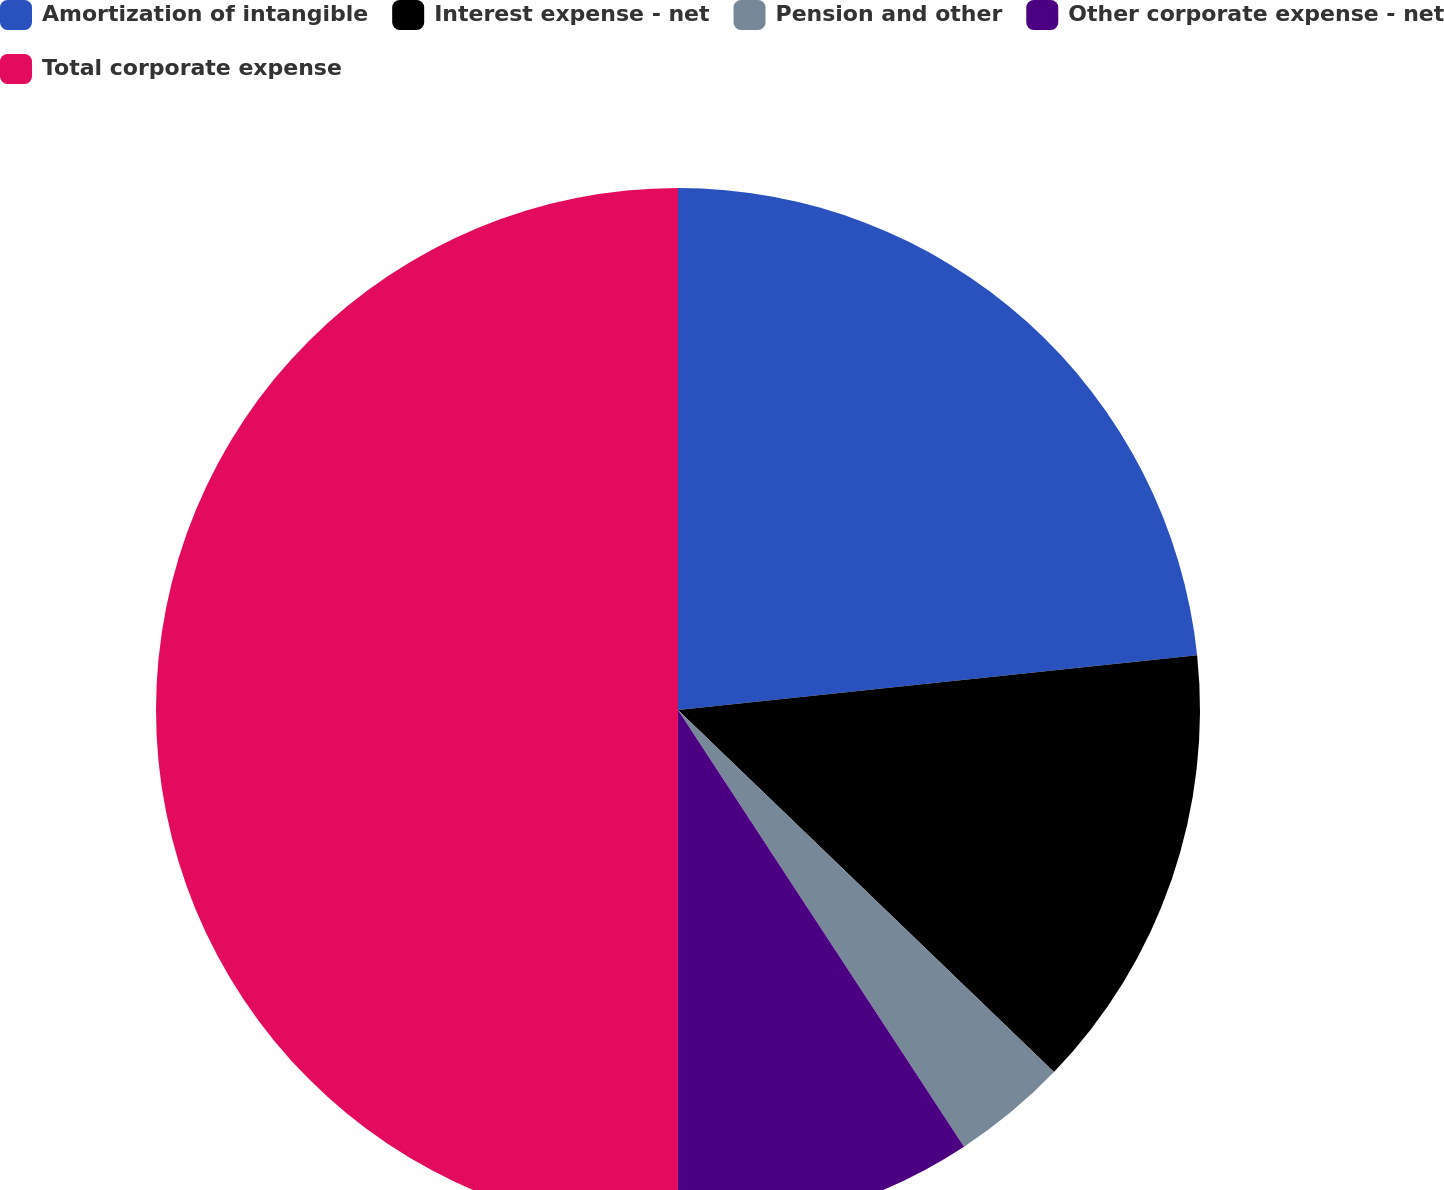<chart> <loc_0><loc_0><loc_500><loc_500><pie_chart><fcel>Amortization of intangible<fcel>Interest expense - net<fcel>Pension and other<fcel>Other corporate expense - net<fcel>Total corporate expense<nl><fcel>23.33%<fcel>13.87%<fcel>3.57%<fcel>9.23%<fcel>50.0%<nl></chart> 